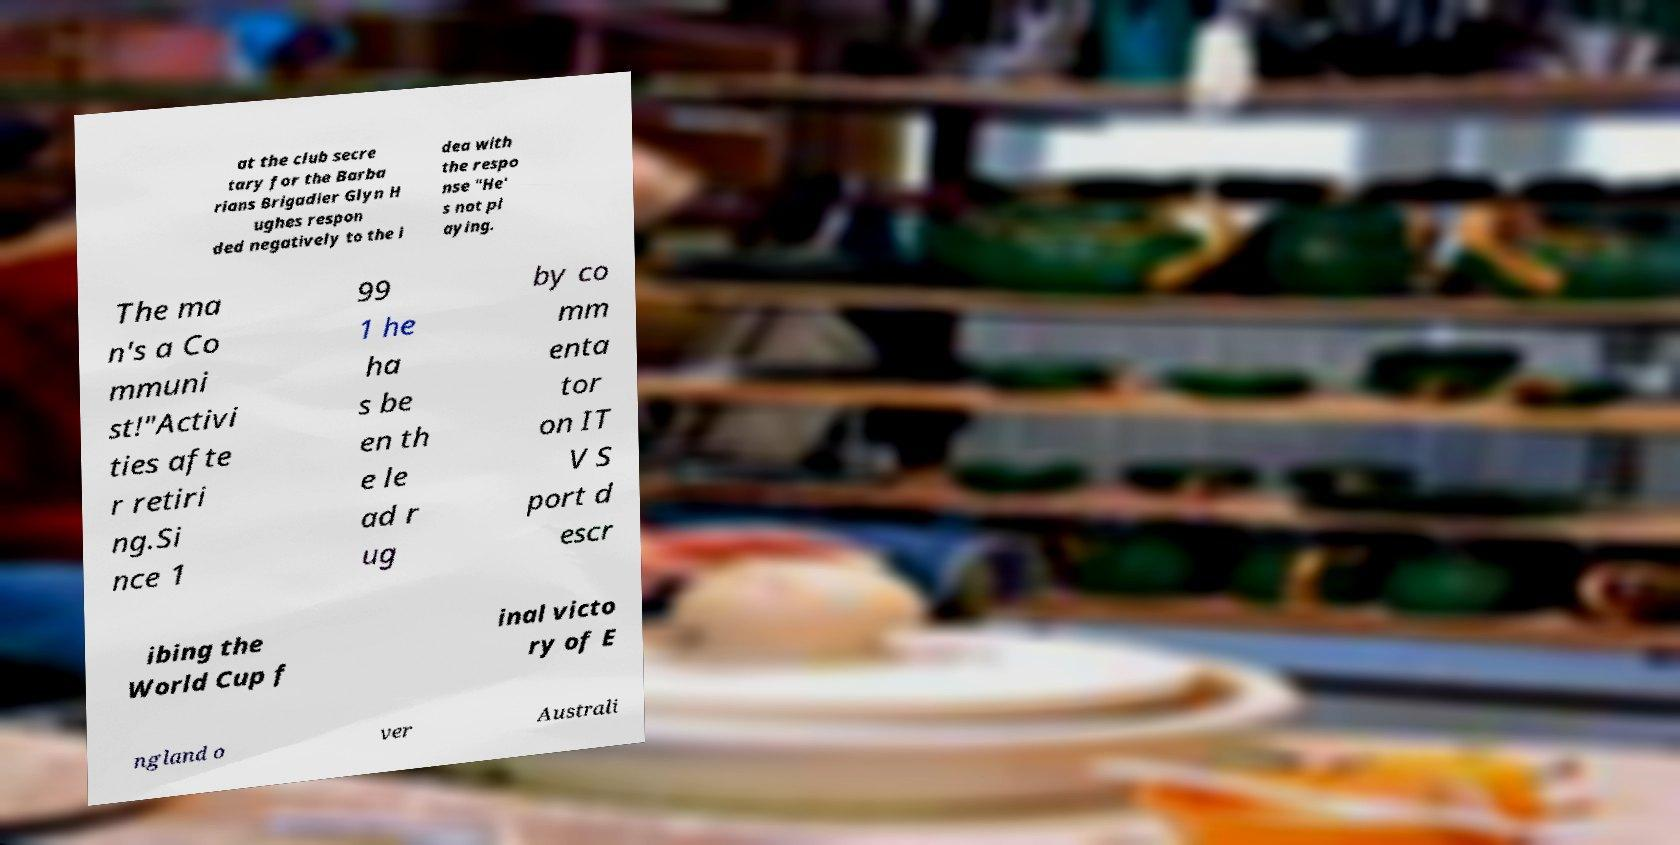I need the written content from this picture converted into text. Can you do that? at the club secre tary for the Barba rians Brigadier Glyn H ughes respon ded negatively to the i dea with the respo nse "He' s not pl aying. The ma n's a Co mmuni st!"Activi ties afte r retiri ng.Si nce 1 99 1 he ha s be en th e le ad r ug by co mm enta tor on IT V S port d escr ibing the World Cup f inal victo ry of E ngland o ver Australi 